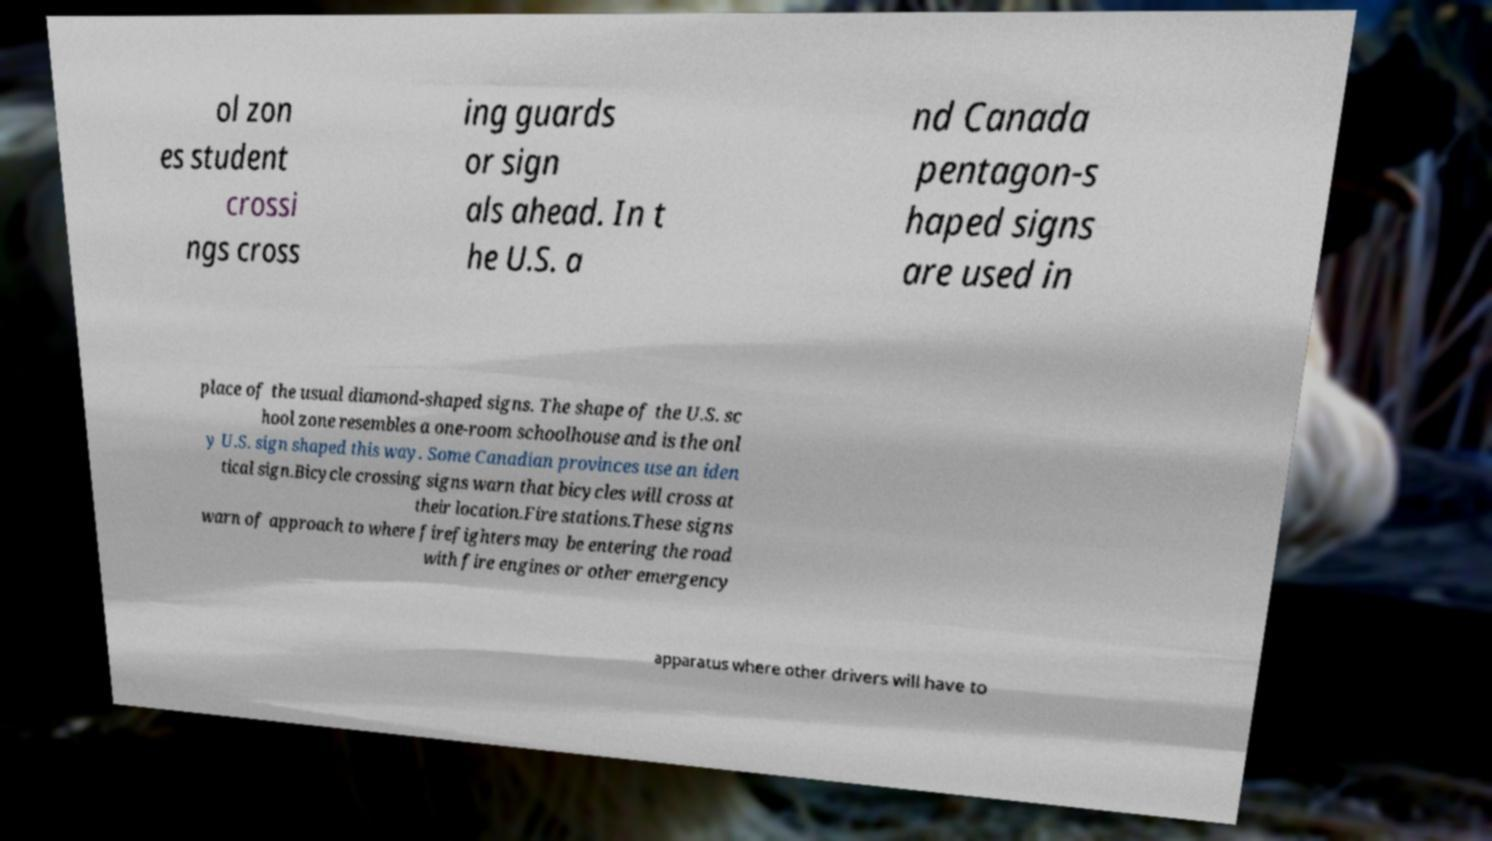What messages or text are displayed in this image? I need them in a readable, typed format. ol zon es student crossi ngs cross ing guards or sign als ahead. In t he U.S. a nd Canada pentagon-s haped signs are used in place of the usual diamond-shaped signs. The shape of the U.S. sc hool zone resembles a one-room schoolhouse and is the onl y U.S. sign shaped this way. Some Canadian provinces use an iden tical sign.Bicycle crossing signs warn that bicycles will cross at their location.Fire stations.These signs warn of approach to where firefighters may be entering the road with fire engines or other emergency apparatus where other drivers will have to 